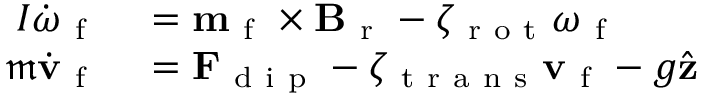Convert formula to latex. <formula><loc_0><loc_0><loc_500><loc_500>\begin{array} { r l } { I \dot { \omega } _ { f } } & = m _ { f } \times B _ { r } - \zeta _ { r o t } \omega _ { f } } \\ { \mathfrak { m } \dot { v } _ { f } } & = F _ { d i p } - \zeta _ { t r a n s } v _ { f } - g \hat { z } } \end{array}</formula> 